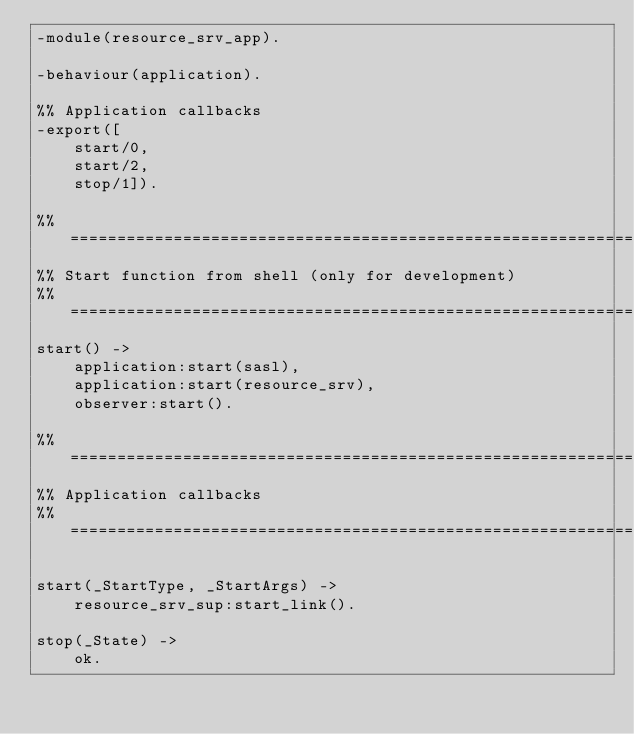<code> <loc_0><loc_0><loc_500><loc_500><_Erlang_>-module(resource_srv_app).

-behaviour(application).

%% Application callbacks
-export([
    start/0,
    start/2,
    stop/1]).

%% ===================================================================
%% Start function from shell (only for development)
%% ===================================================================
start() ->
    application:start(sasl),
    application:start(resource_srv),
    observer:start().

%% ===================================================================
%% Application callbacks
%% ===================================================================

start(_StartType, _StartArgs) ->
    resource_srv_sup:start_link().

stop(_State) ->
    ok.
</code> 